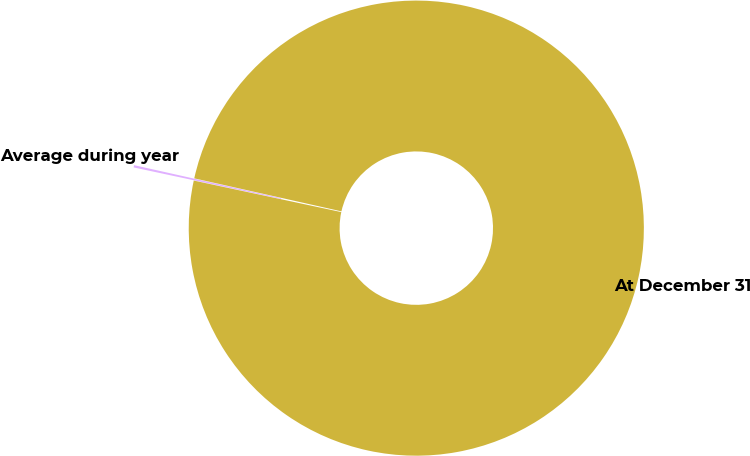<chart> <loc_0><loc_0><loc_500><loc_500><pie_chart><fcel>Average during year<fcel>At December 31<nl><fcel>0.16%<fcel>99.84%<nl></chart> 